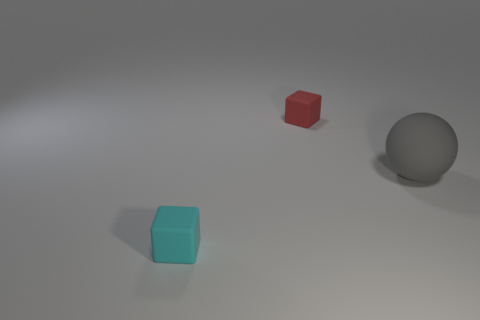Is the large sphere made of the same material as the small red block?
Provide a succinct answer. Yes. What number of big objects are either gray spheres or red cubes?
Offer a very short reply. 1. Are there any big spheres that have the same material as the red object?
Keep it short and to the point. Yes. There is a matte cube left of the red thing; is its size the same as the gray rubber thing?
Offer a very short reply. No. There is a small object in front of the object that is behind the big gray rubber sphere; is there a small thing in front of it?
Your answer should be very brief. No. How many shiny things are large spheres or tiny red things?
Your answer should be compact. 0. What number of other objects are the same shape as the gray object?
Give a very brief answer. 0. Are there more small red things than small red shiny things?
Provide a succinct answer. Yes. There is a block on the right side of the tiny rubber thing that is on the left side of the cube to the right of the tiny cyan thing; what size is it?
Provide a short and direct response. Small. There is a rubber object that is to the right of the red matte cube; how big is it?
Ensure brevity in your answer.  Large. 